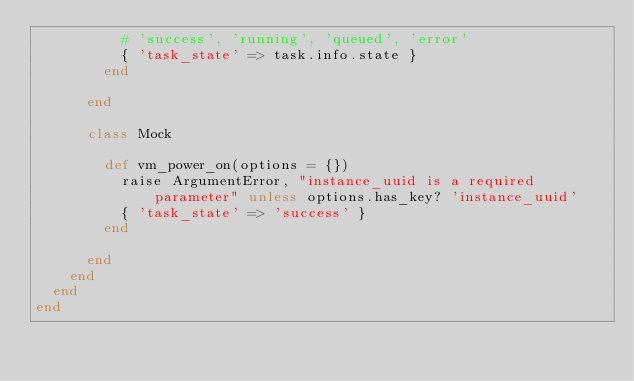<code> <loc_0><loc_0><loc_500><loc_500><_Ruby_>          # 'success', 'running', 'queued', 'error'
          { 'task_state' => task.info.state }
        end

      end

      class Mock

        def vm_power_on(options = {})
          raise ArgumentError, "instance_uuid is a required parameter" unless options.has_key? 'instance_uuid'
          { 'task_state' => 'success' }
        end

      end
    end
  end
end
</code> 